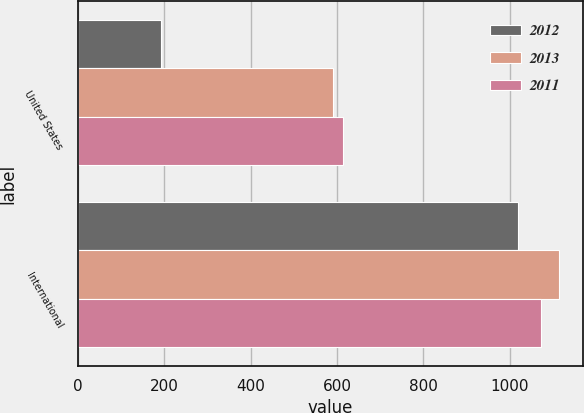Convert chart. <chart><loc_0><loc_0><loc_500><loc_500><stacked_bar_chart><ecel><fcel>United States<fcel>International<nl><fcel>2012<fcel>193<fcel>1019<nl><fcel>2013<fcel>591<fcel>1114<nl><fcel>2011<fcel>613<fcel>1073<nl></chart> 